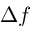Convert formula to latex. <formula><loc_0><loc_0><loc_500><loc_500>\Delta f</formula> 